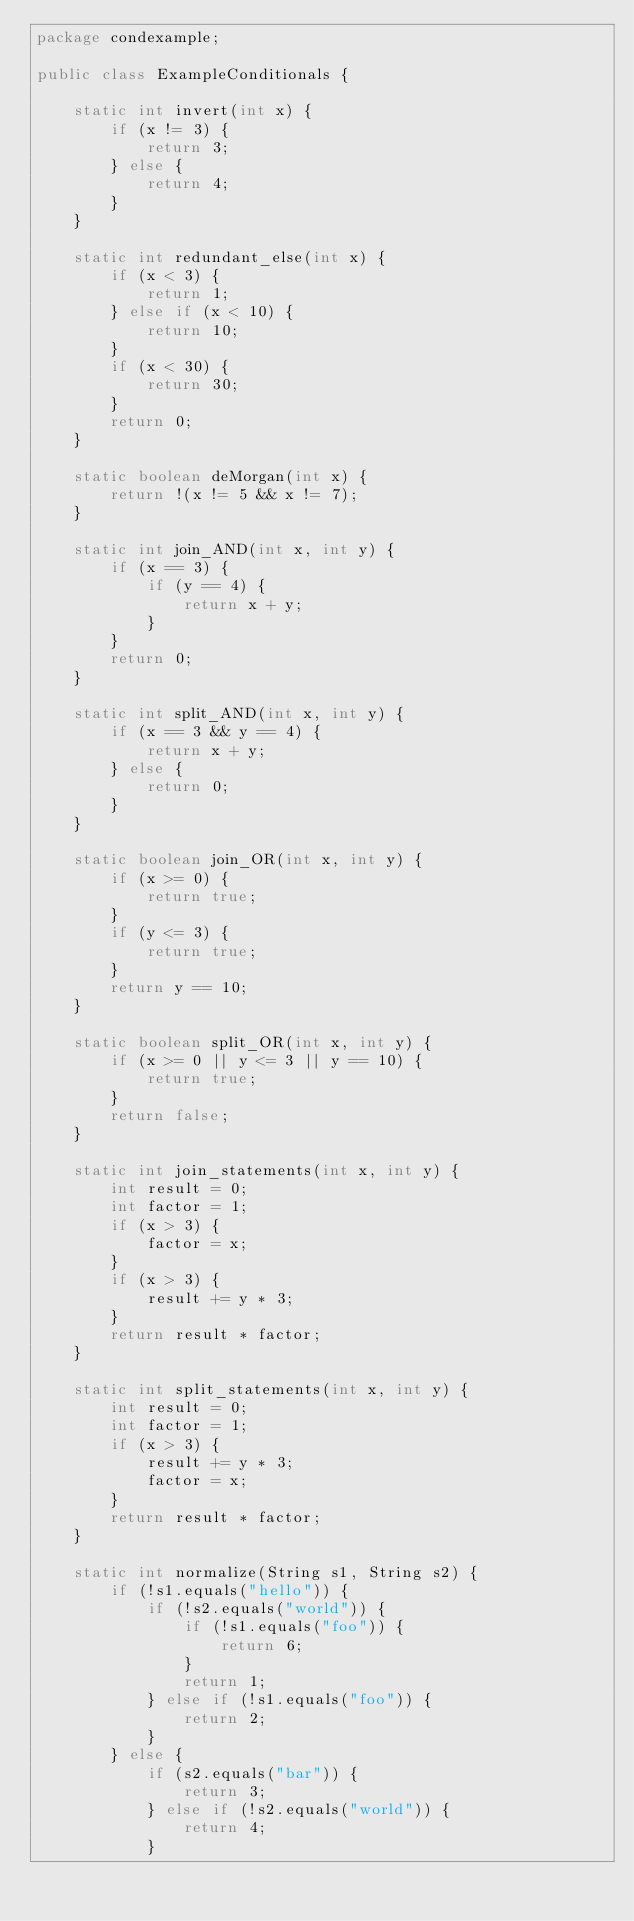Convert code to text. <code><loc_0><loc_0><loc_500><loc_500><_Java_>package condexample;

public class ExampleConditionals {

	static int invert(int x) {
		if (x != 3) {
			return 3;
		} else {
			return 4;
		}
	}

	static int redundant_else(int x) {
		if (x < 3) {
			return 1;
		} else if (x < 10) {
			return 10;
		}
		if (x < 30) {
			return 30;
		}
		return 0;
	}

	static boolean deMorgan(int x) {
		return !(x != 5 && x != 7);
	}

	static int join_AND(int x, int y) {
		if (x == 3) {
			if (y == 4) {
				return x + y;
			}
		}
		return 0;
	}

	static int split_AND(int x, int y) {
		if (x == 3 && y == 4) {
			return x + y;
		} else {
			return 0;
		}
	}

	static boolean join_OR(int x, int y) {
		if (x >= 0) {
			return true;
		}
		if (y <= 3) {
			return true;
		}
		return y == 10;
	}

	static boolean split_OR(int x, int y) {
		if (x >= 0 || y <= 3 || y == 10) {
			return true;
		}
		return false;
	}

	static int join_statements(int x, int y) {
		int result = 0;
		int factor = 1;
		if (x > 3) {
			factor = x;
		}
		if (x > 3) {
			result += y * 3;
		}
		return result * factor;
	}

	static int split_statements(int x, int y) {
		int result = 0;
		int factor = 1;
		if (x > 3) {
			result += y * 3;
			factor = x;
		}
		return result * factor;
	}

	static int normalize(String s1, String s2) {
		if (!s1.equals("hello")) {
			if (!s2.equals("world")) {
				if (!s1.equals("foo")) {
					return 6;
				}
				return 1;
			} else if (!s1.equals("foo")) {
				return 2;
			}
		} else {
			if (s2.equals("bar")) {
				return 3;
			} else if (!s2.equals("world")) {
				return 4;
			}</code> 